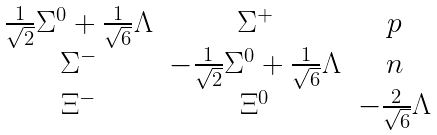<formula> <loc_0><loc_0><loc_500><loc_500>\begin{matrix} \frac { 1 } { \sqrt { 2 } } \Sigma ^ { 0 } + \frac { 1 } { \sqrt { 6 } } \Lambda & \Sigma ^ { + } & p \\ \Sigma ^ { - } & - \frac { 1 } { \sqrt { 2 } } \Sigma ^ { 0 } + \frac { 1 } { \sqrt { 6 } } \Lambda & n \\ \Xi ^ { - } & \Xi ^ { 0 } & - \frac { 2 } { \sqrt { 6 } } \Lambda \end{matrix}</formula> 